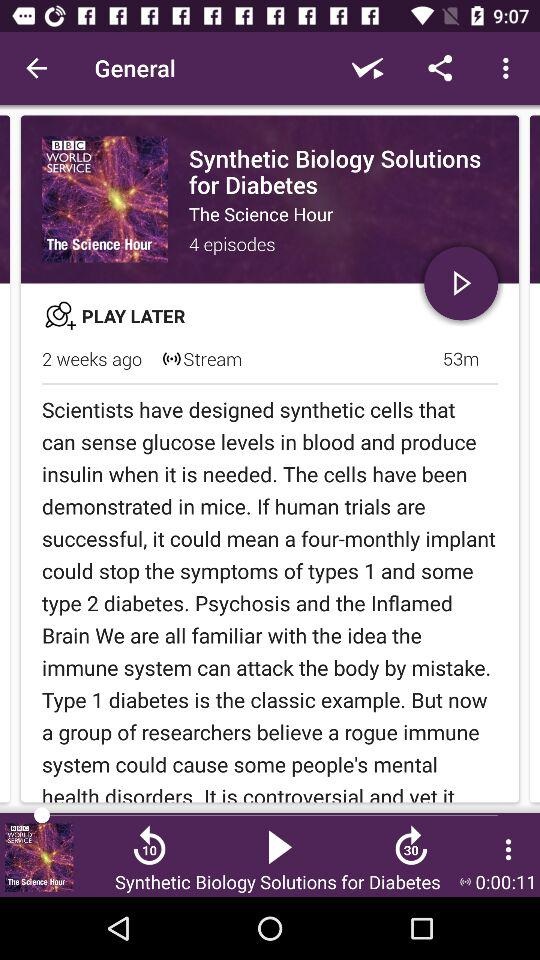When was the post posted? The post was posted 2 weeks ago. 